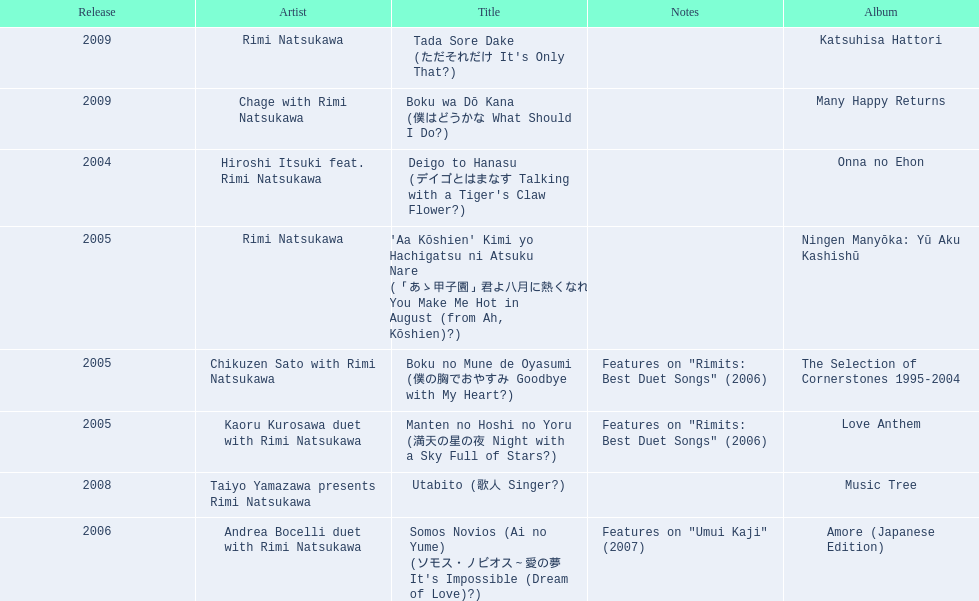How many other appearance did this artist make in 2005? 3. 